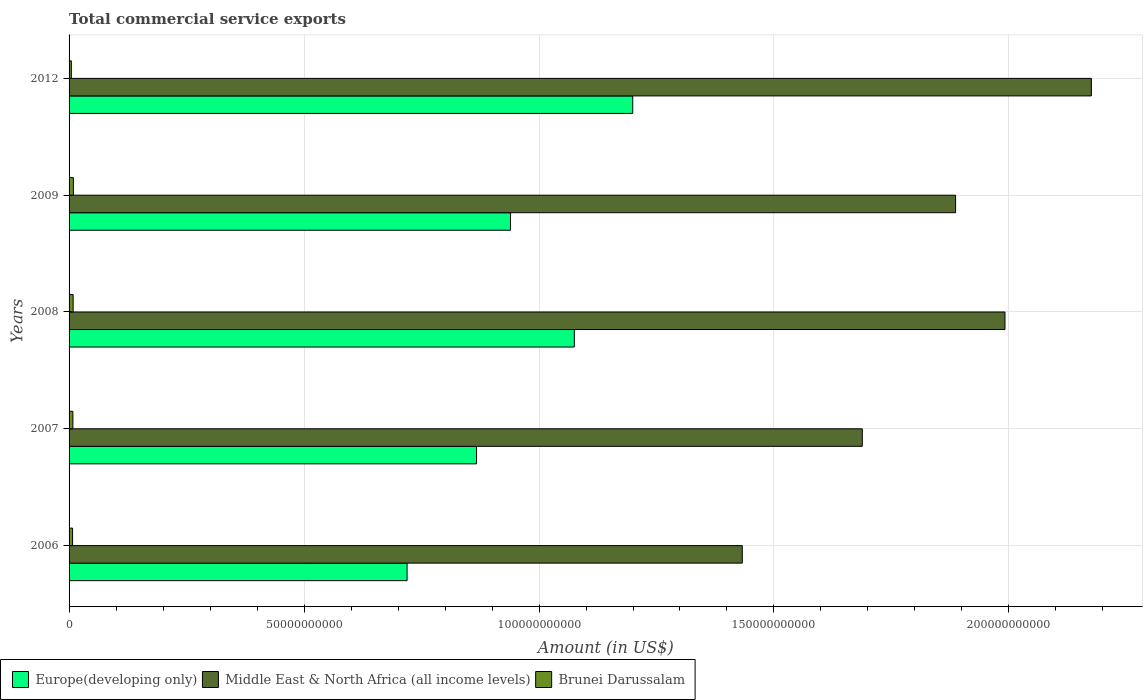How many groups of bars are there?
Your answer should be very brief. 5. Are the number of bars per tick equal to the number of legend labels?
Offer a very short reply. Yes. Are the number of bars on each tick of the Y-axis equal?
Provide a succinct answer. Yes. How many bars are there on the 1st tick from the bottom?
Keep it short and to the point. 3. In how many cases, is the number of bars for a given year not equal to the number of legend labels?
Ensure brevity in your answer.  0. What is the total commercial service exports in Europe(developing only) in 2008?
Offer a very short reply. 1.08e+11. Across all years, what is the maximum total commercial service exports in Europe(developing only)?
Make the answer very short. 1.20e+11. Across all years, what is the minimum total commercial service exports in Europe(developing only)?
Provide a short and direct response. 7.19e+1. In which year was the total commercial service exports in Europe(developing only) minimum?
Give a very brief answer. 2006. What is the total total commercial service exports in Brunei Darussalam in the graph?
Provide a short and direct response. 3.82e+09. What is the difference between the total commercial service exports in Europe(developing only) in 2007 and that in 2008?
Give a very brief answer. -2.08e+1. What is the difference between the total commercial service exports in Europe(developing only) in 2006 and the total commercial service exports in Brunei Darussalam in 2012?
Offer a very short reply. 7.14e+1. What is the average total commercial service exports in Europe(developing only) per year?
Offer a terse response. 9.60e+1. In the year 2006, what is the difference between the total commercial service exports in Europe(developing only) and total commercial service exports in Middle East & North Africa (all income levels)?
Your answer should be very brief. -7.13e+1. What is the ratio of the total commercial service exports in Europe(developing only) in 2006 to that in 2008?
Your answer should be very brief. 0.67. Is the difference between the total commercial service exports in Europe(developing only) in 2006 and 2012 greater than the difference between the total commercial service exports in Middle East & North Africa (all income levels) in 2006 and 2012?
Keep it short and to the point. Yes. What is the difference between the highest and the second highest total commercial service exports in Europe(developing only)?
Keep it short and to the point. 1.24e+1. What is the difference between the highest and the lowest total commercial service exports in Europe(developing only)?
Provide a succinct answer. 4.80e+1. In how many years, is the total commercial service exports in Brunei Darussalam greater than the average total commercial service exports in Brunei Darussalam taken over all years?
Offer a very short reply. 3. What does the 3rd bar from the top in 2007 represents?
Give a very brief answer. Europe(developing only). What does the 3rd bar from the bottom in 2006 represents?
Your response must be concise. Brunei Darussalam. Is it the case that in every year, the sum of the total commercial service exports in Brunei Darussalam and total commercial service exports in Middle East & North Africa (all income levels) is greater than the total commercial service exports in Europe(developing only)?
Give a very brief answer. Yes. How many bars are there?
Give a very brief answer. 15. What is the difference between two consecutive major ticks on the X-axis?
Your response must be concise. 5.00e+1. Does the graph contain any zero values?
Your answer should be compact. No. Where does the legend appear in the graph?
Ensure brevity in your answer.  Bottom left. What is the title of the graph?
Provide a short and direct response. Total commercial service exports. Does "Eritrea" appear as one of the legend labels in the graph?
Give a very brief answer. No. What is the label or title of the X-axis?
Provide a short and direct response. Amount (in US$). What is the label or title of the Y-axis?
Give a very brief answer. Years. What is the Amount (in US$) in Europe(developing only) in 2006?
Your answer should be compact. 7.19e+1. What is the Amount (in US$) in Middle East & North Africa (all income levels) in 2006?
Provide a succinct answer. 1.43e+11. What is the Amount (in US$) of Brunei Darussalam in 2006?
Your response must be concise. 7.45e+08. What is the Amount (in US$) of Europe(developing only) in 2007?
Keep it short and to the point. 8.67e+1. What is the Amount (in US$) in Middle East & North Africa (all income levels) in 2007?
Provide a succinct answer. 1.69e+11. What is the Amount (in US$) of Brunei Darussalam in 2007?
Keep it short and to the point. 8.13e+08. What is the Amount (in US$) of Europe(developing only) in 2008?
Offer a very short reply. 1.08e+11. What is the Amount (in US$) of Middle East & North Africa (all income levels) in 2008?
Offer a very short reply. 1.99e+11. What is the Amount (in US$) in Brunei Darussalam in 2008?
Your answer should be very brief. 8.67e+08. What is the Amount (in US$) of Europe(developing only) in 2009?
Your response must be concise. 9.39e+1. What is the Amount (in US$) of Middle East & North Africa (all income levels) in 2009?
Make the answer very short. 1.89e+11. What is the Amount (in US$) in Brunei Darussalam in 2009?
Provide a short and direct response. 9.15e+08. What is the Amount (in US$) of Europe(developing only) in 2012?
Ensure brevity in your answer.  1.20e+11. What is the Amount (in US$) in Middle East & North Africa (all income levels) in 2012?
Provide a succinct answer. 2.18e+11. What is the Amount (in US$) of Brunei Darussalam in 2012?
Your answer should be very brief. 4.83e+08. Across all years, what is the maximum Amount (in US$) in Europe(developing only)?
Make the answer very short. 1.20e+11. Across all years, what is the maximum Amount (in US$) in Middle East & North Africa (all income levels)?
Your response must be concise. 2.18e+11. Across all years, what is the maximum Amount (in US$) of Brunei Darussalam?
Keep it short and to the point. 9.15e+08. Across all years, what is the minimum Amount (in US$) in Europe(developing only)?
Your answer should be very brief. 7.19e+1. Across all years, what is the minimum Amount (in US$) of Middle East & North Africa (all income levels)?
Offer a terse response. 1.43e+11. Across all years, what is the minimum Amount (in US$) of Brunei Darussalam?
Give a very brief answer. 4.83e+08. What is the total Amount (in US$) of Europe(developing only) in the graph?
Your response must be concise. 4.80e+11. What is the total Amount (in US$) of Middle East & North Africa (all income levels) in the graph?
Provide a short and direct response. 9.17e+11. What is the total Amount (in US$) of Brunei Darussalam in the graph?
Offer a terse response. 3.82e+09. What is the difference between the Amount (in US$) of Europe(developing only) in 2006 and that in 2007?
Keep it short and to the point. -1.48e+1. What is the difference between the Amount (in US$) of Middle East & North Africa (all income levels) in 2006 and that in 2007?
Keep it short and to the point. -2.55e+1. What is the difference between the Amount (in US$) of Brunei Darussalam in 2006 and that in 2007?
Your answer should be compact. -6.88e+07. What is the difference between the Amount (in US$) of Europe(developing only) in 2006 and that in 2008?
Your answer should be very brief. -3.56e+1. What is the difference between the Amount (in US$) in Middle East & North Africa (all income levels) in 2006 and that in 2008?
Keep it short and to the point. -5.59e+1. What is the difference between the Amount (in US$) of Brunei Darussalam in 2006 and that in 2008?
Provide a succinct answer. -1.23e+08. What is the difference between the Amount (in US$) in Europe(developing only) in 2006 and that in 2009?
Your answer should be very brief. -2.20e+1. What is the difference between the Amount (in US$) in Middle East & North Africa (all income levels) in 2006 and that in 2009?
Offer a very short reply. -4.54e+1. What is the difference between the Amount (in US$) of Brunei Darussalam in 2006 and that in 2009?
Ensure brevity in your answer.  -1.70e+08. What is the difference between the Amount (in US$) in Europe(developing only) in 2006 and that in 2012?
Offer a terse response. -4.80e+1. What is the difference between the Amount (in US$) of Middle East & North Africa (all income levels) in 2006 and that in 2012?
Your answer should be compact. -7.43e+1. What is the difference between the Amount (in US$) of Brunei Darussalam in 2006 and that in 2012?
Provide a short and direct response. 2.62e+08. What is the difference between the Amount (in US$) in Europe(developing only) in 2007 and that in 2008?
Your answer should be very brief. -2.08e+1. What is the difference between the Amount (in US$) of Middle East & North Africa (all income levels) in 2007 and that in 2008?
Your answer should be compact. -3.04e+1. What is the difference between the Amount (in US$) of Brunei Darussalam in 2007 and that in 2008?
Provide a succinct answer. -5.39e+07. What is the difference between the Amount (in US$) of Europe(developing only) in 2007 and that in 2009?
Make the answer very short. -7.22e+09. What is the difference between the Amount (in US$) in Middle East & North Africa (all income levels) in 2007 and that in 2009?
Provide a succinct answer. -1.99e+1. What is the difference between the Amount (in US$) of Brunei Darussalam in 2007 and that in 2009?
Your response must be concise. -1.02e+08. What is the difference between the Amount (in US$) in Europe(developing only) in 2007 and that in 2012?
Your response must be concise. -3.32e+1. What is the difference between the Amount (in US$) in Middle East & North Africa (all income levels) in 2007 and that in 2012?
Give a very brief answer. -4.87e+1. What is the difference between the Amount (in US$) of Brunei Darussalam in 2007 and that in 2012?
Offer a terse response. 3.30e+08. What is the difference between the Amount (in US$) in Europe(developing only) in 2008 and that in 2009?
Provide a succinct answer. 1.36e+1. What is the difference between the Amount (in US$) in Middle East & North Africa (all income levels) in 2008 and that in 2009?
Your response must be concise. 1.05e+1. What is the difference between the Amount (in US$) of Brunei Darussalam in 2008 and that in 2009?
Make the answer very short. -4.77e+07. What is the difference between the Amount (in US$) in Europe(developing only) in 2008 and that in 2012?
Keep it short and to the point. -1.24e+1. What is the difference between the Amount (in US$) of Middle East & North Africa (all income levels) in 2008 and that in 2012?
Ensure brevity in your answer.  -1.84e+1. What is the difference between the Amount (in US$) in Brunei Darussalam in 2008 and that in 2012?
Your answer should be compact. 3.84e+08. What is the difference between the Amount (in US$) of Europe(developing only) in 2009 and that in 2012?
Give a very brief answer. -2.60e+1. What is the difference between the Amount (in US$) of Middle East & North Africa (all income levels) in 2009 and that in 2012?
Ensure brevity in your answer.  -2.89e+1. What is the difference between the Amount (in US$) of Brunei Darussalam in 2009 and that in 2012?
Your answer should be compact. 4.32e+08. What is the difference between the Amount (in US$) in Europe(developing only) in 2006 and the Amount (in US$) in Middle East & North Africa (all income levels) in 2007?
Make the answer very short. -9.69e+1. What is the difference between the Amount (in US$) in Europe(developing only) in 2006 and the Amount (in US$) in Brunei Darussalam in 2007?
Offer a very short reply. 7.11e+1. What is the difference between the Amount (in US$) in Middle East & North Africa (all income levels) in 2006 and the Amount (in US$) in Brunei Darussalam in 2007?
Provide a succinct answer. 1.42e+11. What is the difference between the Amount (in US$) of Europe(developing only) in 2006 and the Amount (in US$) of Middle East & North Africa (all income levels) in 2008?
Your answer should be compact. -1.27e+11. What is the difference between the Amount (in US$) of Europe(developing only) in 2006 and the Amount (in US$) of Brunei Darussalam in 2008?
Keep it short and to the point. 7.11e+1. What is the difference between the Amount (in US$) of Middle East & North Africa (all income levels) in 2006 and the Amount (in US$) of Brunei Darussalam in 2008?
Ensure brevity in your answer.  1.42e+11. What is the difference between the Amount (in US$) of Europe(developing only) in 2006 and the Amount (in US$) of Middle East & North Africa (all income levels) in 2009?
Offer a terse response. -1.17e+11. What is the difference between the Amount (in US$) of Europe(developing only) in 2006 and the Amount (in US$) of Brunei Darussalam in 2009?
Offer a terse response. 7.10e+1. What is the difference between the Amount (in US$) in Middle East & North Africa (all income levels) in 2006 and the Amount (in US$) in Brunei Darussalam in 2009?
Provide a succinct answer. 1.42e+11. What is the difference between the Amount (in US$) of Europe(developing only) in 2006 and the Amount (in US$) of Middle East & North Africa (all income levels) in 2012?
Your response must be concise. -1.46e+11. What is the difference between the Amount (in US$) in Europe(developing only) in 2006 and the Amount (in US$) in Brunei Darussalam in 2012?
Keep it short and to the point. 7.14e+1. What is the difference between the Amount (in US$) in Middle East & North Africa (all income levels) in 2006 and the Amount (in US$) in Brunei Darussalam in 2012?
Your answer should be compact. 1.43e+11. What is the difference between the Amount (in US$) of Europe(developing only) in 2007 and the Amount (in US$) of Middle East & North Africa (all income levels) in 2008?
Your response must be concise. -1.12e+11. What is the difference between the Amount (in US$) of Europe(developing only) in 2007 and the Amount (in US$) of Brunei Darussalam in 2008?
Keep it short and to the point. 8.58e+1. What is the difference between the Amount (in US$) in Middle East & North Africa (all income levels) in 2007 and the Amount (in US$) in Brunei Darussalam in 2008?
Provide a short and direct response. 1.68e+11. What is the difference between the Amount (in US$) of Europe(developing only) in 2007 and the Amount (in US$) of Middle East & North Africa (all income levels) in 2009?
Offer a terse response. -1.02e+11. What is the difference between the Amount (in US$) of Europe(developing only) in 2007 and the Amount (in US$) of Brunei Darussalam in 2009?
Your response must be concise. 8.58e+1. What is the difference between the Amount (in US$) in Middle East & North Africa (all income levels) in 2007 and the Amount (in US$) in Brunei Darussalam in 2009?
Provide a short and direct response. 1.68e+11. What is the difference between the Amount (in US$) of Europe(developing only) in 2007 and the Amount (in US$) of Middle East & North Africa (all income levels) in 2012?
Offer a terse response. -1.31e+11. What is the difference between the Amount (in US$) of Europe(developing only) in 2007 and the Amount (in US$) of Brunei Darussalam in 2012?
Your answer should be compact. 8.62e+1. What is the difference between the Amount (in US$) in Middle East & North Africa (all income levels) in 2007 and the Amount (in US$) in Brunei Darussalam in 2012?
Offer a terse response. 1.68e+11. What is the difference between the Amount (in US$) of Europe(developing only) in 2008 and the Amount (in US$) of Middle East & North Africa (all income levels) in 2009?
Provide a short and direct response. -8.11e+1. What is the difference between the Amount (in US$) in Europe(developing only) in 2008 and the Amount (in US$) in Brunei Darussalam in 2009?
Make the answer very short. 1.07e+11. What is the difference between the Amount (in US$) of Middle East & North Africa (all income levels) in 2008 and the Amount (in US$) of Brunei Darussalam in 2009?
Provide a succinct answer. 1.98e+11. What is the difference between the Amount (in US$) of Europe(developing only) in 2008 and the Amount (in US$) of Middle East & North Africa (all income levels) in 2012?
Your answer should be very brief. -1.10e+11. What is the difference between the Amount (in US$) in Europe(developing only) in 2008 and the Amount (in US$) in Brunei Darussalam in 2012?
Give a very brief answer. 1.07e+11. What is the difference between the Amount (in US$) in Middle East & North Africa (all income levels) in 2008 and the Amount (in US$) in Brunei Darussalam in 2012?
Keep it short and to the point. 1.99e+11. What is the difference between the Amount (in US$) in Europe(developing only) in 2009 and the Amount (in US$) in Middle East & North Africa (all income levels) in 2012?
Provide a succinct answer. -1.24e+11. What is the difference between the Amount (in US$) in Europe(developing only) in 2009 and the Amount (in US$) in Brunei Darussalam in 2012?
Keep it short and to the point. 9.34e+1. What is the difference between the Amount (in US$) in Middle East & North Africa (all income levels) in 2009 and the Amount (in US$) in Brunei Darussalam in 2012?
Offer a very short reply. 1.88e+11. What is the average Amount (in US$) in Europe(developing only) per year?
Keep it short and to the point. 9.60e+1. What is the average Amount (in US$) in Middle East & North Africa (all income levels) per year?
Offer a very short reply. 1.83e+11. What is the average Amount (in US$) in Brunei Darussalam per year?
Your answer should be very brief. 7.65e+08. In the year 2006, what is the difference between the Amount (in US$) of Europe(developing only) and Amount (in US$) of Middle East & North Africa (all income levels)?
Give a very brief answer. -7.13e+1. In the year 2006, what is the difference between the Amount (in US$) of Europe(developing only) and Amount (in US$) of Brunei Darussalam?
Your answer should be very brief. 7.12e+1. In the year 2006, what is the difference between the Amount (in US$) of Middle East & North Africa (all income levels) and Amount (in US$) of Brunei Darussalam?
Offer a terse response. 1.43e+11. In the year 2007, what is the difference between the Amount (in US$) of Europe(developing only) and Amount (in US$) of Middle East & North Africa (all income levels)?
Keep it short and to the point. -8.21e+1. In the year 2007, what is the difference between the Amount (in US$) of Europe(developing only) and Amount (in US$) of Brunei Darussalam?
Offer a terse response. 8.59e+1. In the year 2007, what is the difference between the Amount (in US$) in Middle East & North Africa (all income levels) and Amount (in US$) in Brunei Darussalam?
Your response must be concise. 1.68e+11. In the year 2008, what is the difference between the Amount (in US$) in Europe(developing only) and Amount (in US$) in Middle East & North Africa (all income levels)?
Keep it short and to the point. -9.16e+1. In the year 2008, what is the difference between the Amount (in US$) of Europe(developing only) and Amount (in US$) of Brunei Darussalam?
Give a very brief answer. 1.07e+11. In the year 2008, what is the difference between the Amount (in US$) in Middle East & North Africa (all income levels) and Amount (in US$) in Brunei Darussalam?
Your answer should be very brief. 1.98e+11. In the year 2009, what is the difference between the Amount (in US$) in Europe(developing only) and Amount (in US$) in Middle East & North Africa (all income levels)?
Give a very brief answer. -9.47e+1. In the year 2009, what is the difference between the Amount (in US$) of Europe(developing only) and Amount (in US$) of Brunei Darussalam?
Your answer should be very brief. 9.30e+1. In the year 2009, what is the difference between the Amount (in US$) in Middle East & North Africa (all income levels) and Amount (in US$) in Brunei Darussalam?
Offer a very short reply. 1.88e+11. In the year 2012, what is the difference between the Amount (in US$) of Europe(developing only) and Amount (in US$) of Middle East & North Africa (all income levels)?
Provide a short and direct response. -9.76e+1. In the year 2012, what is the difference between the Amount (in US$) in Europe(developing only) and Amount (in US$) in Brunei Darussalam?
Your answer should be compact. 1.19e+11. In the year 2012, what is the difference between the Amount (in US$) of Middle East & North Africa (all income levels) and Amount (in US$) of Brunei Darussalam?
Your response must be concise. 2.17e+11. What is the ratio of the Amount (in US$) of Europe(developing only) in 2006 to that in 2007?
Ensure brevity in your answer.  0.83. What is the ratio of the Amount (in US$) of Middle East & North Africa (all income levels) in 2006 to that in 2007?
Your answer should be compact. 0.85. What is the ratio of the Amount (in US$) in Brunei Darussalam in 2006 to that in 2007?
Keep it short and to the point. 0.92. What is the ratio of the Amount (in US$) in Europe(developing only) in 2006 to that in 2008?
Offer a terse response. 0.67. What is the ratio of the Amount (in US$) in Middle East & North Africa (all income levels) in 2006 to that in 2008?
Your answer should be compact. 0.72. What is the ratio of the Amount (in US$) of Brunei Darussalam in 2006 to that in 2008?
Make the answer very short. 0.86. What is the ratio of the Amount (in US$) in Europe(developing only) in 2006 to that in 2009?
Your answer should be compact. 0.77. What is the ratio of the Amount (in US$) in Middle East & North Africa (all income levels) in 2006 to that in 2009?
Provide a succinct answer. 0.76. What is the ratio of the Amount (in US$) in Brunei Darussalam in 2006 to that in 2009?
Give a very brief answer. 0.81. What is the ratio of the Amount (in US$) in Europe(developing only) in 2006 to that in 2012?
Your answer should be very brief. 0.6. What is the ratio of the Amount (in US$) in Middle East & North Africa (all income levels) in 2006 to that in 2012?
Keep it short and to the point. 0.66. What is the ratio of the Amount (in US$) in Brunei Darussalam in 2006 to that in 2012?
Make the answer very short. 1.54. What is the ratio of the Amount (in US$) in Europe(developing only) in 2007 to that in 2008?
Your response must be concise. 0.81. What is the ratio of the Amount (in US$) in Middle East & North Africa (all income levels) in 2007 to that in 2008?
Make the answer very short. 0.85. What is the ratio of the Amount (in US$) of Brunei Darussalam in 2007 to that in 2008?
Your answer should be very brief. 0.94. What is the ratio of the Amount (in US$) in Europe(developing only) in 2007 to that in 2009?
Offer a very short reply. 0.92. What is the ratio of the Amount (in US$) in Middle East & North Africa (all income levels) in 2007 to that in 2009?
Your answer should be very brief. 0.89. What is the ratio of the Amount (in US$) of Brunei Darussalam in 2007 to that in 2009?
Your response must be concise. 0.89. What is the ratio of the Amount (in US$) of Europe(developing only) in 2007 to that in 2012?
Your answer should be compact. 0.72. What is the ratio of the Amount (in US$) in Middle East & North Africa (all income levels) in 2007 to that in 2012?
Your response must be concise. 0.78. What is the ratio of the Amount (in US$) in Brunei Darussalam in 2007 to that in 2012?
Provide a succinct answer. 1.68. What is the ratio of the Amount (in US$) of Europe(developing only) in 2008 to that in 2009?
Your answer should be compact. 1.14. What is the ratio of the Amount (in US$) in Middle East & North Africa (all income levels) in 2008 to that in 2009?
Your response must be concise. 1.06. What is the ratio of the Amount (in US$) in Brunei Darussalam in 2008 to that in 2009?
Ensure brevity in your answer.  0.95. What is the ratio of the Amount (in US$) in Europe(developing only) in 2008 to that in 2012?
Provide a short and direct response. 0.9. What is the ratio of the Amount (in US$) of Middle East & North Africa (all income levels) in 2008 to that in 2012?
Provide a short and direct response. 0.92. What is the ratio of the Amount (in US$) of Brunei Darussalam in 2008 to that in 2012?
Give a very brief answer. 1.8. What is the ratio of the Amount (in US$) of Europe(developing only) in 2009 to that in 2012?
Offer a terse response. 0.78. What is the ratio of the Amount (in US$) in Middle East & North Africa (all income levels) in 2009 to that in 2012?
Make the answer very short. 0.87. What is the ratio of the Amount (in US$) in Brunei Darussalam in 2009 to that in 2012?
Keep it short and to the point. 1.89. What is the difference between the highest and the second highest Amount (in US$) of Europe(developing only)?
Your answer should be very brief. 1.24e+1. What is the difference between the highest and the second highest Amount (in US$) in Middle East & North Africa (all income levels)?
Make the answer very short. 1.84e+1. What is the difference between the highest and the second highest Amount (in US$) in Brunei Darussalam?
Your answer should be compact. 4.77e+07. What is the difference between the highest and the lowest Amount (in US$) of Europe(developing only)?
Your answer should be very brief. 4.80e+1. What is the difference between the highest and the lowest Amount (in US$) of Middle East & North Africa (all income levels)?
Provide a short and direct response. 7.43e+1. What is the difference between the highest and the lowest Amount (in US$) of Brunei Darussalam?
Provide a succinct answer. 4.32e+08. 